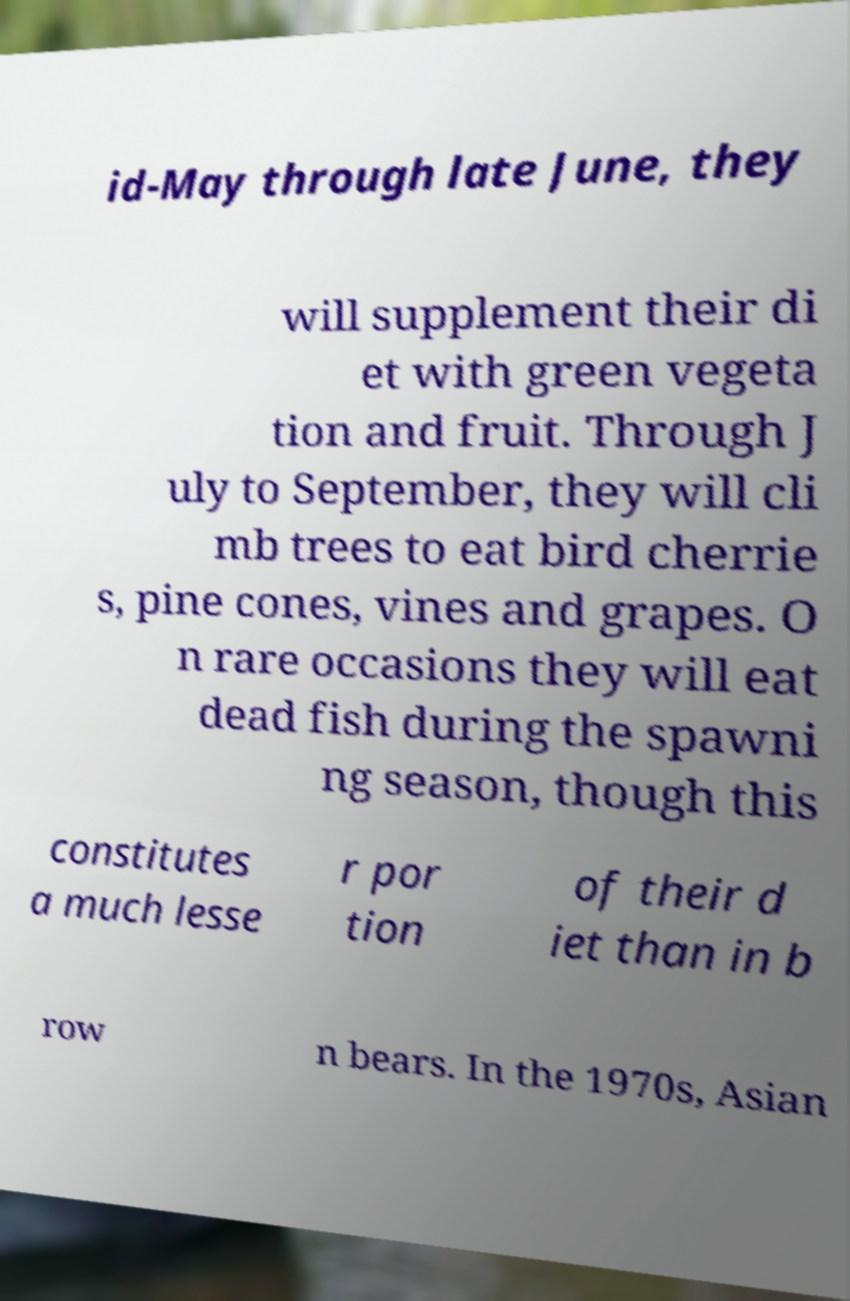Can you read and provide the text displayed in the image?This photo seems to have some interesting text. Can you extract and type it out for me? id-May through late June, they will supplement their di et with green vegeta tion and fruit. Through J uly to September, they will cli mb trees to eat bird cherrie s, pine cones, vines and grapes. O n rare occasions they will eat dead fish during the spawni ng season, though this constitutes a much lesse r por tion of their d iet than in b row n bears. In the 1970s, Asian 